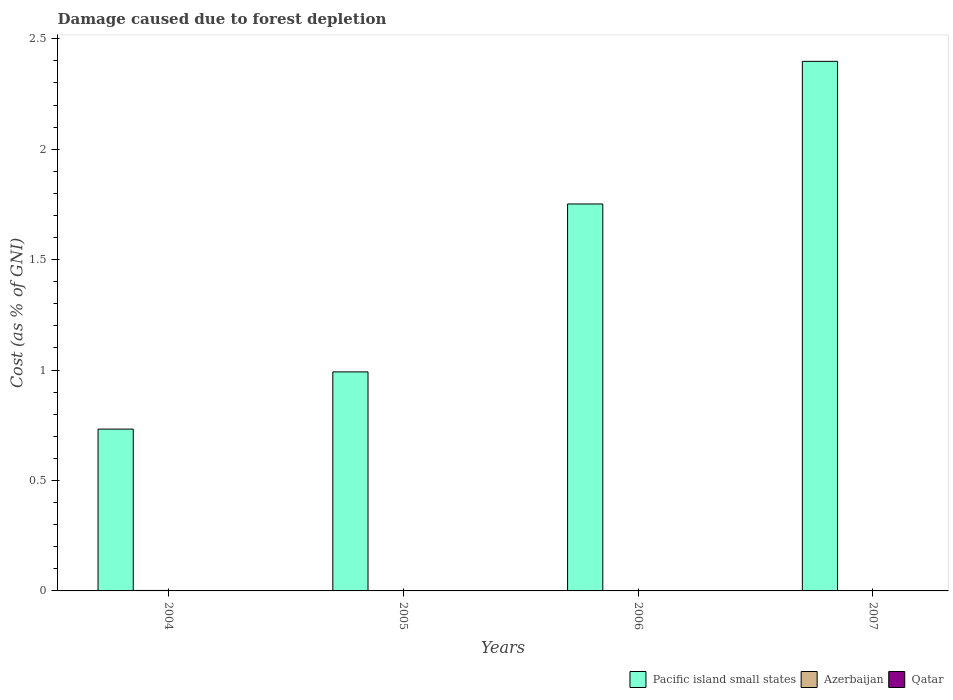How many different coloured bars are there?
Keep it short and to the point. 3. How many groups of bars are there?
Offer a very short reply. 4. Are the number of bars per tick equal to the number of legend labels?
Provide a succinct answer. Yes. Are the number of bars on each tick of the X-axis equal?
Your answer should be very brief. Yes. How many bars are there on the 4th tick from the right?
Provide a succinct answer. 3. What is the label of the 2nd group of bars from the left?
Your answer should be compact. 2005. What is the cost of damage caused due to forest depletion in Qatar in 2004?
Make the answer very short. 0. Across all years, what is the maximum cost of damage caused due to forest depletion in Qatar?
Offer a terse response. 0. Across all years, what is the minimum cost of damage caused due to forest depletion in Azerbaijan?
Give a very brief answer. 0. In which year was the cost of damage caused due to forest depletion in Pacific island small states maximum?
Your answer should be compact. 2007. In which year was the cost of damage caused due to forest depletion in Qatar minimum?
Your answer should be very brief. 2006. What is the total cost of damage caused due to forest depletion in Azerbaijan in the graph?
Provide a short and direct response. 0.01. What is the difference between the cost of damage caused due to forest depletion in Qatar in 2004 and that in 2005?
Make the answer very short. 8.437434619111203e-5. What is the difference between the cost of damage caused due to forest depletion in Azerbaijan in 2007 and the cost of damage caused due to forest depletion in Pacific island small states in 2005?
Provide a succinct answer. -0.99. What is the average cost of damage caused due to forest depletion in Pacific island small states per year?
Keep it short and to the point. 1.47. In the year 2005, what is the difference between the cost of damage caused due to forest depletion in Qatar and cost of damage caused due to forest depletion in Azerbaijan?
Give a very brief answer. -0. In how many years, is the cost of damage caused due to forest depletion in Qatar greater than 1.6 %?
Your response must be concise. 0. What is the ratio of the cost of damage caused due to forest depletion in Azerbaijan in 2004 to that in 2006?
Ensure brevity in your answer.  1.84. What is the difference between the highest and the second highest cost of damage caused due to forest depletion in Pacific island small states?
Keep it short and to the point. 0.65. What is the difference between the highest and the lowest cost of damage caused due to forest depletion in Pacific island small states?
Provide a short and direct response. 1.67. In how many years, is the cost of damage caused due to forest depletion in Azerbaijan greater than the average cost of damage caused due to forest depletion in Azerbaijan taken over all years?
Ensure brevity in your answer.  2. Is the sum of the cost of damage caused due to forest depletion in Pacific island small states in 2004 and 2006 greater than the maximum cost of damage caused due to forest depletion in Qatar across all years?
Keep it short and to the point. Yes. What does the 3rd bar from the left in 2007 represents?
Your answer should be very brief. Qatar. What does the 2nd bar from the right in 2005 represents?
Your response must be concise. Azerbaijan. Is it the case that in every year, the sum of the cost of damage caused due to forest depletion in Azerbaijan and cost of damage caused due to forest depletion in Pacific island small states is greater than the cost of damage caused due to forest depletion in Qatar?
Your answer should be compact. Yes. How many years are there in the graph?
Make the answer very short. 4. What is the difference between two consecutive major ticks on the Y-axis?
Give a very brief answer. 0.5. Are the values on the major ticks of Y-axis written in scientific E-notation?
Offer a very short reply. No. Does the graph contain any zero values?
Provide a short and direct response. No. Does the graph contain grids?
Keep it short and to the point. No. How many legend labels are there?
Give a very brief answer. 3. How are the legend labels stacked?
Provide a short and direct response. Horizontal. What is the title of the graph?
Keep it short and to the point. Damage caused due to forest depletion. What is the label or title of the X-axis?
Your answer should be compact. Years. What is the label or title of the Y-axis?
Your answer should be very brief. Cost (as % of GNI). What is the Cost (as % of GNI) in Pacific island small states in 2004?
Your response must be concise. 0.73. What is the Cost (as % of GNI) in Azerbaijan in 2004?
Your response must be concise. 0. What is the Cost (as % of GNI) of Qatar in 2004?
Offer a terse response. 0. What is the Cost (as % of GNI) in Pacific island small states in 2005?
Offer a terse response. 0.99. What is the Cost (as % of GNI) in Azerbaijan in 2005?
Provide a short and direct response. 0. What is the Cost (as % of GNI) in Qatar in 2005?
Your answer should be compact. 0. What is the Cost (as % of GNI) in Pacific island small states in 2006?
Ensure brevity in your answer.  1.75. What is the Cost (as % of GNI) of Azerbaijan in 2006?
Provide a succinct answer. 0. What is the Cost (as % of GNI) of Qatar in 2006?
Your answer should be very brief. 0. What is the Cost (as % of GNI) of Pacific island small states in 2007?
Offer a very short reply. 2.4. What is the Cost (as % of GNI) in Azerbaijan in 2007?
Provide a succinct answer. 0. What is the Cost (as % of GNI) in Qatar in 2007?
Provide a short and direct response. 0. Across all years, what is the maximum Cost (as % of GNI) in Pacific island small states?
Offer a terse response. 2.4. Across all years, what is the maximum Cost (as % of GNI) in Azerbaijan?
Your answer should be compact. 0. Across all years, what is the maximum Cost (as % of GNI) of Qatar?
Ensure brevity in your answer.  0. Across all years, what is the minimum Cost (as % of GNI) in Pacific island small states?
Your answer should be very brief. 0.73. Across all years, what is the minimum Cost (as % of GNI) of Azerbaijan?
Your response must be concise. 0. Across all years, what is the minimum Cost (as % of GNI) in Qatar?
Keep it short and to the point. 0. What is the total Cost (as % of GNI) of Pacific island small states in the graph?
Your response must be concise. 5.87. What is the total Cost (as % of GNI) in Azerbaijan in the graph?
Provide a short and direct response. 0.01. What is the total Cost (as % of GNI) of Qatar in the graph?
Provide a short and direct response. 0. What is the difference between the Cost (as % of GNI) of Pacific island small states in 2004 and that in 2005?
Your answer should be compact. -0.26. What is the difference between the Cost (as % of GNI) in Azerbaijan in 2004 and that in 2005?
Your response must be concise. 0. What is the difference between the Cost (as % of GNI) of Pacific island small states in 2004 and that in 2006?
Your response must be concise. -1.02. What is the difference between the Cost (as % of GNI) in Azerbaijan in 2004 and that in 2006?
Make the answer very short. 0. What is the difference between the Cost (as % of GNI) of Pacific island small states in 2004 and that in 2007?
Offer a very short reply. -1.67. What is the difference between the Cost (as % of GNI) of Azerbaijan in 2004 and that in 2007?
Your answer should be very brief. 0. What is the difference between the Cost (as % of GNI) in Qatar in 2004 and that in 2007?
Your answer should be compact. 0. What is the difference between the Cost (as % of GNI) in Pacific island small states in 2005 and that in 2006?
Give a very brief answer. -0.76. What is the difference between the Cost (as % of GNI) in Azerbaijan in 2005 and that in 2006?
Offer a very short reply. 0. What is the difference between the Cost (as % of GNI) in Qatar in 2005 and that in 2006?
Make the answer very short. 0. What is the difference between the Cost (as % of GNI) of Pacific island small states in 2005 and that in 2007?
Ensure brevity in your answer.  -1.41. What is the difference between the Cost (as % of GNI) in Azerbaijan in 2005 and that in 2007?
Your answer should be very brief. 0. What is the difference between the Cost (as % of GNI) in Qatar in 2005 and that in 2007?
Provide a short and direct response. 0. What is the difference between the Cost (as % of GNI) of Pacific island small states in 2006 and that in 2007?
Provide a short and direct response. -0.65. What is the difference between the Cost (as % of GNI) in Azerbaijan in 2006 and that in 2007?
Give a very brief answer. 0. What is the difference between the Cost (as % of GNI) of Qatar in 2006 and that in 2007?
Offer a terse response. -0. What is the difference between the Cost (as % of GNI) of Pacific island small states in 2004 and the Cost (as % of GNI) of Azerbaijan in 2005?
Make the answer very short. 0.73. What is the difference between the Cost (as % of GNI) of Pacific island small states in 2004 and the Cost (as % of GNI) of Qatar in 2005?
Your response must be concise. 0.73. What is the difference between the Cost (as % of GNI) in Azerbaijan in 2004 and the Cost (as % of GNI) in Qatar in 2005?
Offer a very short reply. 0. What is the difference between the Cost (as % of GNI) of Pacific island small states in 2004 and the Cost (as % of GNI) of Azerbaijan in 2006?
Your answer should be very brief. 0.73. What is the difference between the Cost (as % of GNI) of Pacific island small states in 2004 and the Cost (as % of GNI) of Qatar in 2006?
Provide a short and direct response. 0.73. What is the difference between the Cost (as % of GNI) of Azerbaijan in 2004 and the Cost (as % of GNI) of Qatar in 2006?
Your answer should be compact. 0. What is the difference between the Cost (as % of GNI) of Pacific island small states in 2004 and the Cost (as % of GNI) of Azerbaijan in 2007?
Your answer should be very brief. 0.73. What is the difference between the Cost (as % of GNI) of Pacific island small states in 2004 and the Cost (as % of GNI) of Qatar in 2007?
Provide a short and direct response. 0.73. What is the difference between the Cost (as % of GNI) in Azerbaijan in 2004 and the Cost (as % of GNI) in Qatar in 2007?
Offer a very short reply. 0. What is the difference between the Cost (as % of GNI) of Pacific island small states in 2005 and the Cost (as % of GNI) of Azerbaijan in 2006?
Your answer should be compact. 0.99. What is the difference between the Cost (as % of GNI) in Pacific island small states in 2005 and the Cost (as % of GNI) in Qatar in 2006?
Give a very brief answer. 0.99. What is the difference between the Cost (as % of GNI) in Azerbaijan in 2005 and the Cost (as % of GNI) in Qatar in 2006?
Offer a terse response. 0. What is the difference between the Cost (as % of GNI) of Pacific island small states in 2005 and the Cost (as % of GNI) of Azerbaijan in 2007?
Your answer should be very brief. 0.99. What is the difference between the Cost (as % of GNI) of Pacific island small states in 2005 and the Cost (as % of GNI) of Qatar in 2007?
Offer a terse response. 0.99. What is the difference between the Cost (as % of GNI) of Azerbaijan in 2005 and the Cost (as % of GNI) of Qatar in 2007?
Your response must be concise. 0. What is the difference between the Cost (as % of GNI) in Pacific island small states in 2006 and the Cost (as % of GNI) in Azerbaijan in 2007?
Offer a very short reply. 1.75. What is the difference between the Cost (as % of GNI) of Pacific island small states in 2006 and the Cost (as % of GNI) of Qatar in 2007?
Offer a terse response. 1.75. What is the difference between the Cost (as % of GNI) of Azerbaijan in 2006 and the Cost (as % of GNI) of Qatar in 2007?
Offer a very short reply. 0. What is the average Cost (as % of GNI) of Pacific island small states per year?
Offer a very short reply. 1.47. What is the average Cost (as % of GNI) of Azerbaijan per year?
Make the answer very short. 0. What is the average Cost (as % of GNI) in Qatar per year?
Ensure brevity in your answer.  0. In the year 2004, what is the difference between the Cost (as % of GNI) of Pacific island small states and Cost (as % of GNI) of Azerbaijan?
Offer a very short reply. 0.73. In the year 2004, what is the difference between the Cost (as % of GNI) in Pacific island small states and Cost (as % of GNI) in Qatar?
Keep it short and to the point. 0.73. In the year 2004, what is the difference between the Cost (as % of GNI) in Azerbaijan and Cost (as % of GNI) in Qatar?
Your answer should be very brief. 0. In the year 2005, what is the difference between the Cost (as % of GNI) of Pacific island small states and Cost (as % of GNI) of Azerbaijan?
Your response must be concise. 0.99. In the year 2005, what is the difference between the Cost (as % of GNI) of Azerbaijan and Cost (as % of GNI) of Qatar?
Offer a terse response. 0. In the year 2006, what is the difference between the Cost (as % of GNI) of Pacific island small states and Cost (as % of GNI) of Azerbaijan?
Keep it short and to the point. 1.75. In the year 2006, what is the difference between the Cost (as % of GNI) in Pacific island small states and Cost (as % of GNI) in Qatar?
Your answer should be compact. 1.75. In the year 2006, what is the difference between the Cost (as % of GNI) of Azerbaijan and Cost (as % of GNI) of Qatar?
Provide a succinct answer. 0. In the year 2007, what is the difference between the Cost (as % of GNI) in Pacific island small states and Cost (as % of GNI) in Azerbaijan?
Your answer should be compact. 2.4. In the year 2007, what is the difference between the Cost (as % of GNI) of Pacific island small states and Cost (as % of GNI) of Qatar?
Keep it short and to the point. 2.4. In the year 2007, what is the difference between the Cost (as % of GNI) of Azerbaijan and Cost (as % of GNI) of Qatar?
Offer a terse response. 0. What is the ratio of the Cost (as % of GNI) in Pacific island small states in 2004 to that in 2005?
Provide a succinct answer. 0.74. What is the ratio of the Cost (as % of GNI) of Azerbaijan in 2004 to that in 2005?
Provide a succinct answer. 1.45. What is the ratio of the Cost (as % of GNI) of Qatar in 2004 to that in 2005?
Offer a very short reply. 1.31. What is the ratio of the Cost (as % of GNI) in Pacific island small states in 2004 to that in 2006?
Your response must be concise. 0.42. What is the ratio of the Cost (as % of GNI) in Azerbaijan in 2004 to that in 2006?
Provide a short and direct response. 1.84. What is the ratio of the Cost (as % of GNI) of Qatar in 2004 to that in 2006?
Give a very brief answer. 1.51. What is the ratio of the Cost (as % of GNI) in Pacific island small states in 2004 to that in 2007?
Provide a short and direct response. 0.31. What is the ratio of the Cost (as % of GNI) in Azerbaijan in 2004 to that in 2007?
Your answer should be compact. 2.44. What is the ratio of the Cost (as % of GNI) in Qatar in 2004 to that in 2007?
Provide a succinct answer. 1.42. What is the ratio of the Cost (as % of GNI) of Pacific island small states in 2005 to that in 2006?
Your response must be concise. 0.57. What is the ratio of the Cost (as % of GNI) of Azerbaijan in 2005 to that in 2006?
Provide a short and direct response. 1.27. What is the ratio of the Cost (as % of GNI) of Qatar in 2005 to that in 2006?
Provide a short and direct response. 1.15. What is the ratio of the Cost (as % of GNI) of Pacific island small states in 2005 to that in 2007?
Offer a terse response. 0.41. What is the ratio of the Cost (as % of GNI) in Azerbaijan in 2005 to that in 2007?
Offer a very short reply. 1.69. What is the ratio of the Cost (as % of GNI) of Qatar in 2005 to that in 2007?
Your response must be concise. 1.09. What is the ratio of the Cost (as % of GNI) of Pacific island small states in 2006 to that in 2007?
Keep it short and to the point. 0.73. What is the ratio of the Cost (as % of GNI) of Azerbaijan in 2006 to that in 2007?
Your response must be concise. 1.33. What is the ratio of the Cost (as % of GNI) in Qatar in 2006 to that in 2007?
Your answer should be very brief. 0.94. What is the difference between the highest and the second highest Cost (as % of GNI) in Pacific island small states?
Your answer should be very brief. 0.65. What is the difference between the highest and the second highest Cost (as % of GNI) in Azerbaijan?
Offer a very short reply. 0. What is the difference between the highest and the lowest Cost (as % of GNI) of Pacific island small states?
Provide a short and direct response. 1.67. What is the difference between the highest and the lowest Cost (as % of GNI) of Azerbaijan?
Provide a succinct answer. 0. 